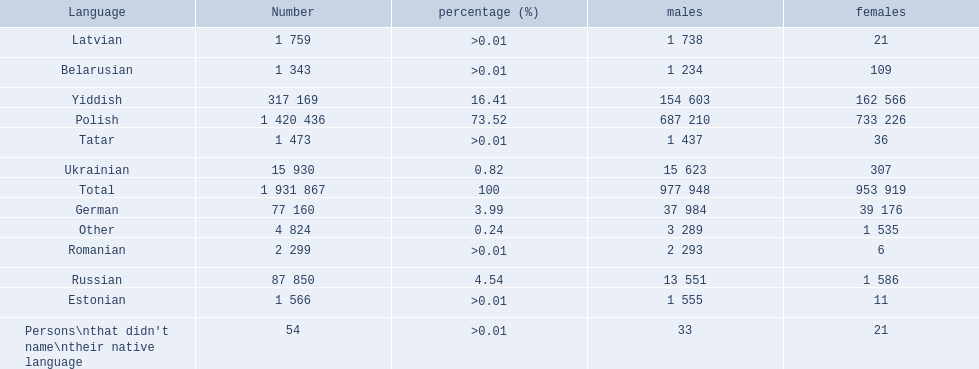What were all the languages? Polish, Yiddish, Russian, German, Ukrainian, Romanian, Latvian, Estonian, Tatar, Belarusian, Other, Persons\nthat didn't name\ntheir native language. For these, how many people spoke them? 1 420 436, 317 169, 87 850, 77 160, 15 930, 2 299, 1 759, 1 566, 1 473, 1 343, 4 824, 54. Of these, which is the largest number of speakers? 1 420 436. Which language corresponds to this number? Polish. 